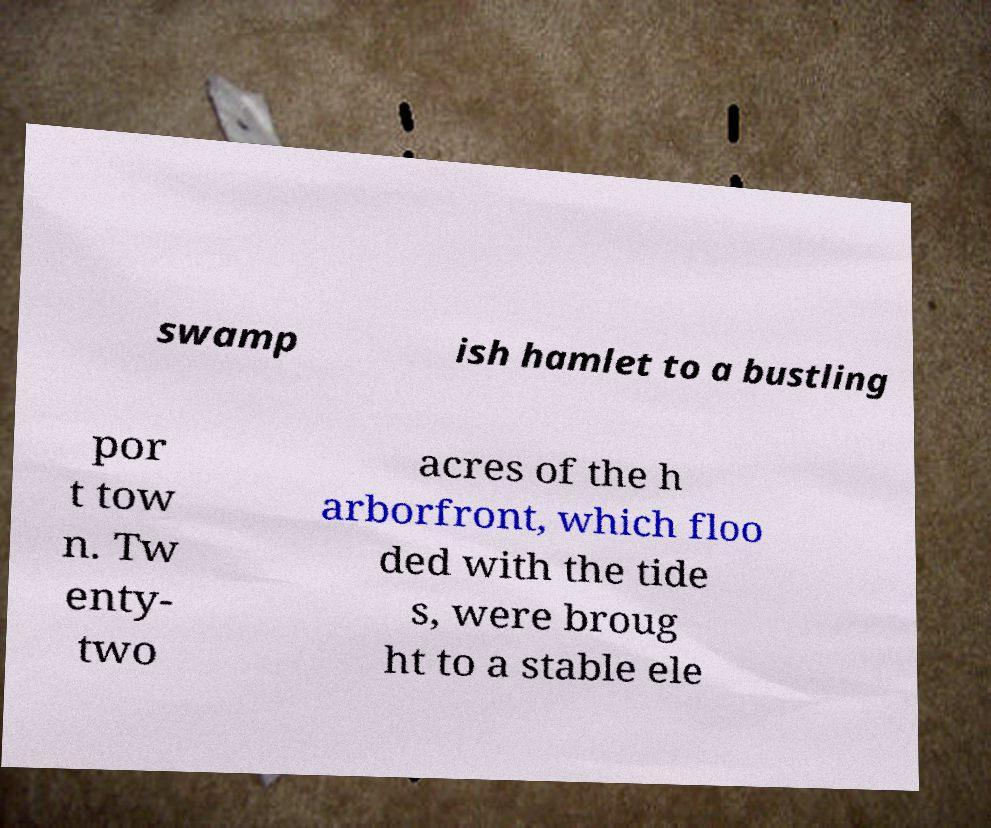Could you assist in decoding the text presented in this image and type it out clearly? swamp ish hamlet to a bustling por t tow n. Tw enty- two acres of the h arborfront, which floo ded with the tide s, were broug ht to a stable ele 